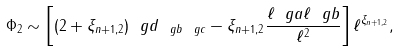<formula> <loc_0><loc_0><loc_500><loc_500>\Phi _ { 2 } \sim \left [ ( 2 + \xi _ { n + 1 , 2 } ) \ g d _ { \ g b \ g c } - \xi _ { n + 1 , 2 } \frac { \ell _ { \ } g a \ell _ { \ } g b } { \ell ^ { 2 } } \right ] \ell ^ { \xi _ { n + 1 , 2 } } ,</formula> 